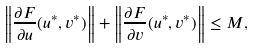Convert formula to latex. <formula><loc_0><loc_0><loc_500><loc_500>\left \| \frac { \partial F } { \partial u } ( u ^ { * } , v ^ { * } ) \right \| + \left \| \frac { \partial F } { \partial v } ( u ^ { * } , v ^ { * } ) \right \| \leq M ,</formula> 